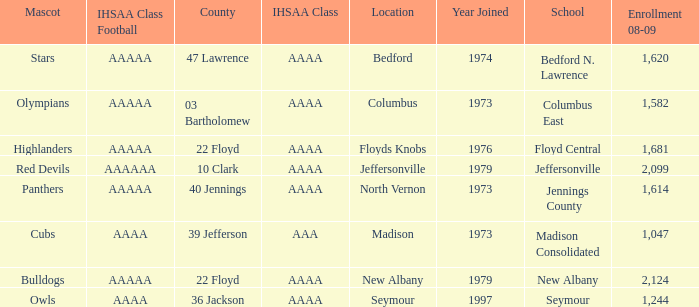What school is in 36 Jackson? Seymour. 